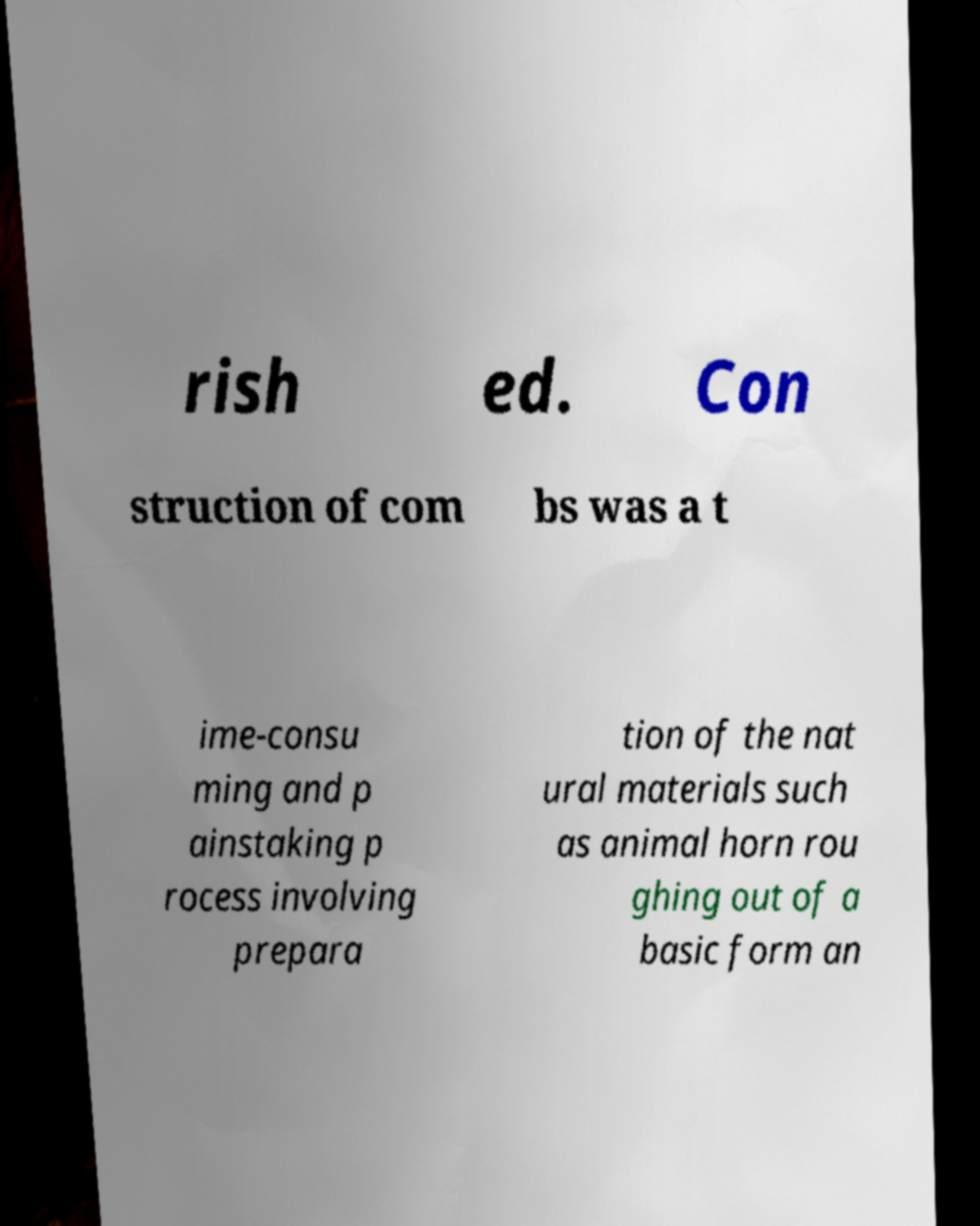There's text embedded in this image that I need extracted. Can you transcribe it verbatim? rish ed. Con struction of com bs was a t ime-consu ming and p ainstaking p rocess involving prepara tion of the nat ural materials such as animal horn rou ghing out of a basic form an 